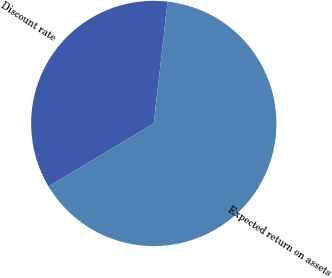Convert chart. <chart><loc_0><loc_0><loc_500><loc_500><pie_chart><fcel>Discount rate<fcel>Expected return on assets<nl><fcel>35.38%<fcel>64.62%<nl></chart> 